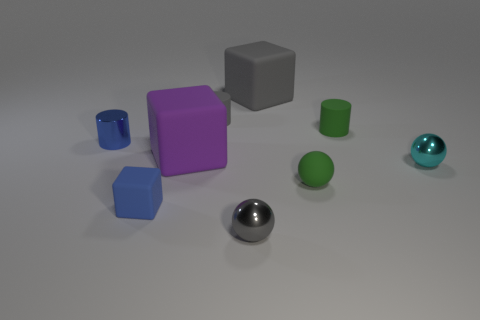Add 1 brown objects. How many objects exist? 10 Subtract all cylinders. How many objects are left? 6 Add 2 blue metallic things. How many blue metallic things are left? 3 Add 2 tiny cyan rubber spheres. How many tiny cyan rubber spheres exist? 2 Subtract 1 blue cubes. How many objects are left? 8 Subtract all blue cubes. Subtract all large purple things. How many objects are left? 7 